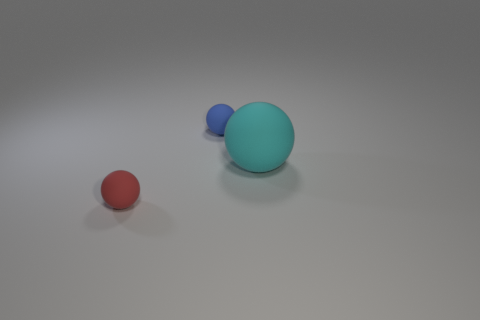There is a red object that is made of the same material as the big cyan object; what is its size?
Your response must be concise. Small. How many other big matte balls are the same color as the large rubber ball?
Your response must be concise. 0. Is the color of the small rubber ball in front of the big cyan rubber ball the same as the big matte thing?
Provide a succinct answer. No. Is the number of cyan things on the left side of the blue matte object the same as the number of blue matte balls that are to the left of the small red rubber thing?
Provide a short and direct response. Yes. Are there any other things that have the same material as the large cyan object?
Offer a very short reply. Yes. There is a small ball to the left of the tiny blue sphere; what is its color?
Ensure brevity in your answer.  Red. Are there an equal number of cyan balls in front of the cyan sphere and small yellow blocks?
Your response must be concise. Yes. What number of other objects are the same shape as the big cyan object?
Your answer should be very brief. 2. There is a cyan object; how many things are in front of it?
Offer a terse response. 1. What size is the matte sphere that is both in front of the tiny blue ball and to the left of the large object?
Your response must be concise. Small. 